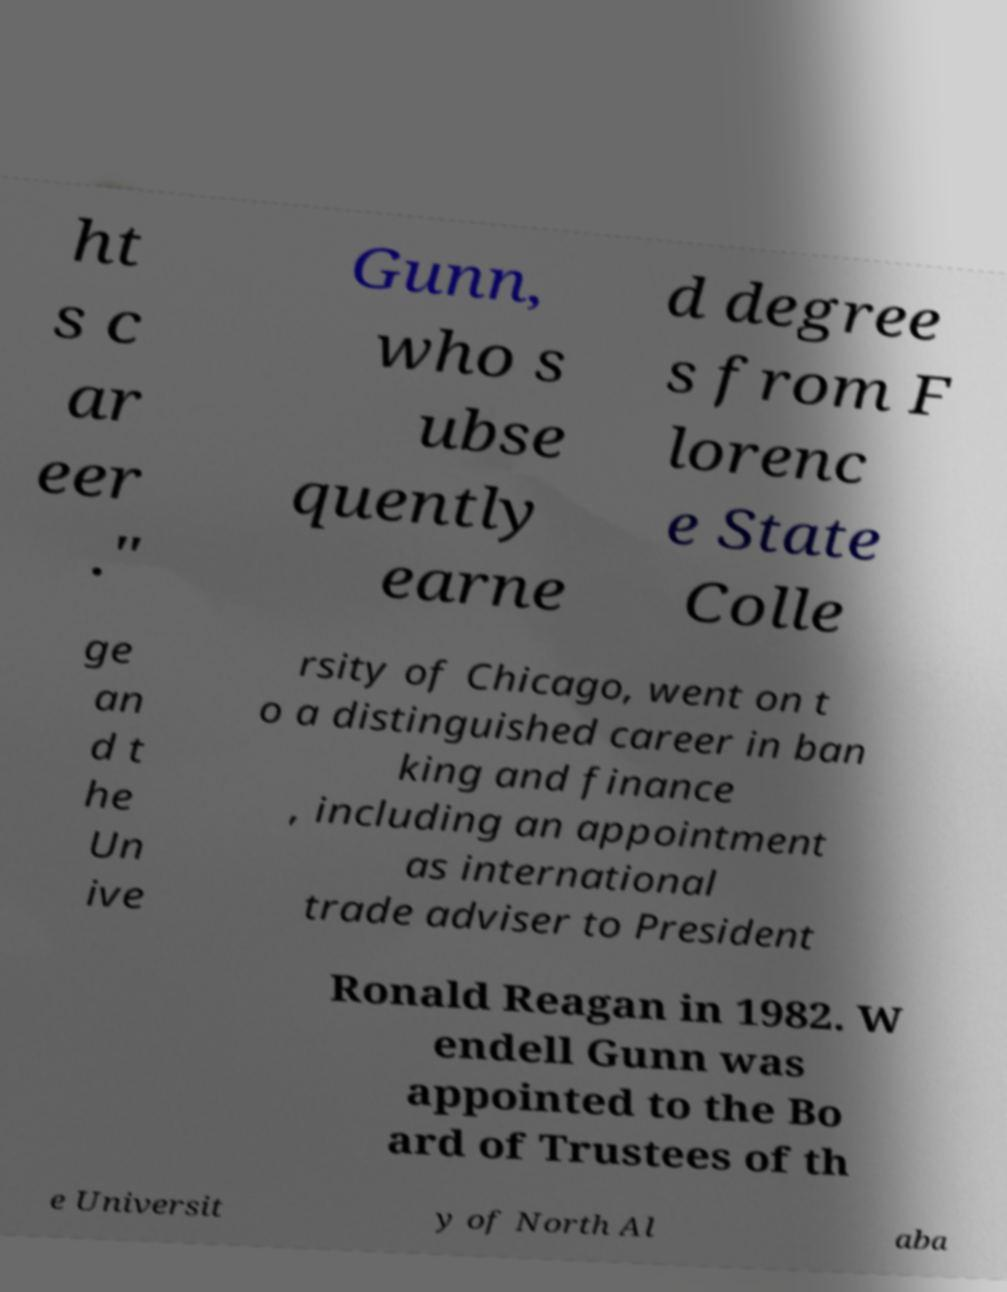Please identify and transcribe the text found in this image. ht s c ar eer ." Gunn, who s ubse quently earne d degree s from F lorenc e State Colle ge an d t he Un ive rsity of Chicago, went on t o a distinguished career in ban king and finance , including an appointment as international trade adviser to President Ronald Reagan in 1982. W endell Gunn was appointed to the Bo ard of Trustees of th e Universit y of North Al aba 